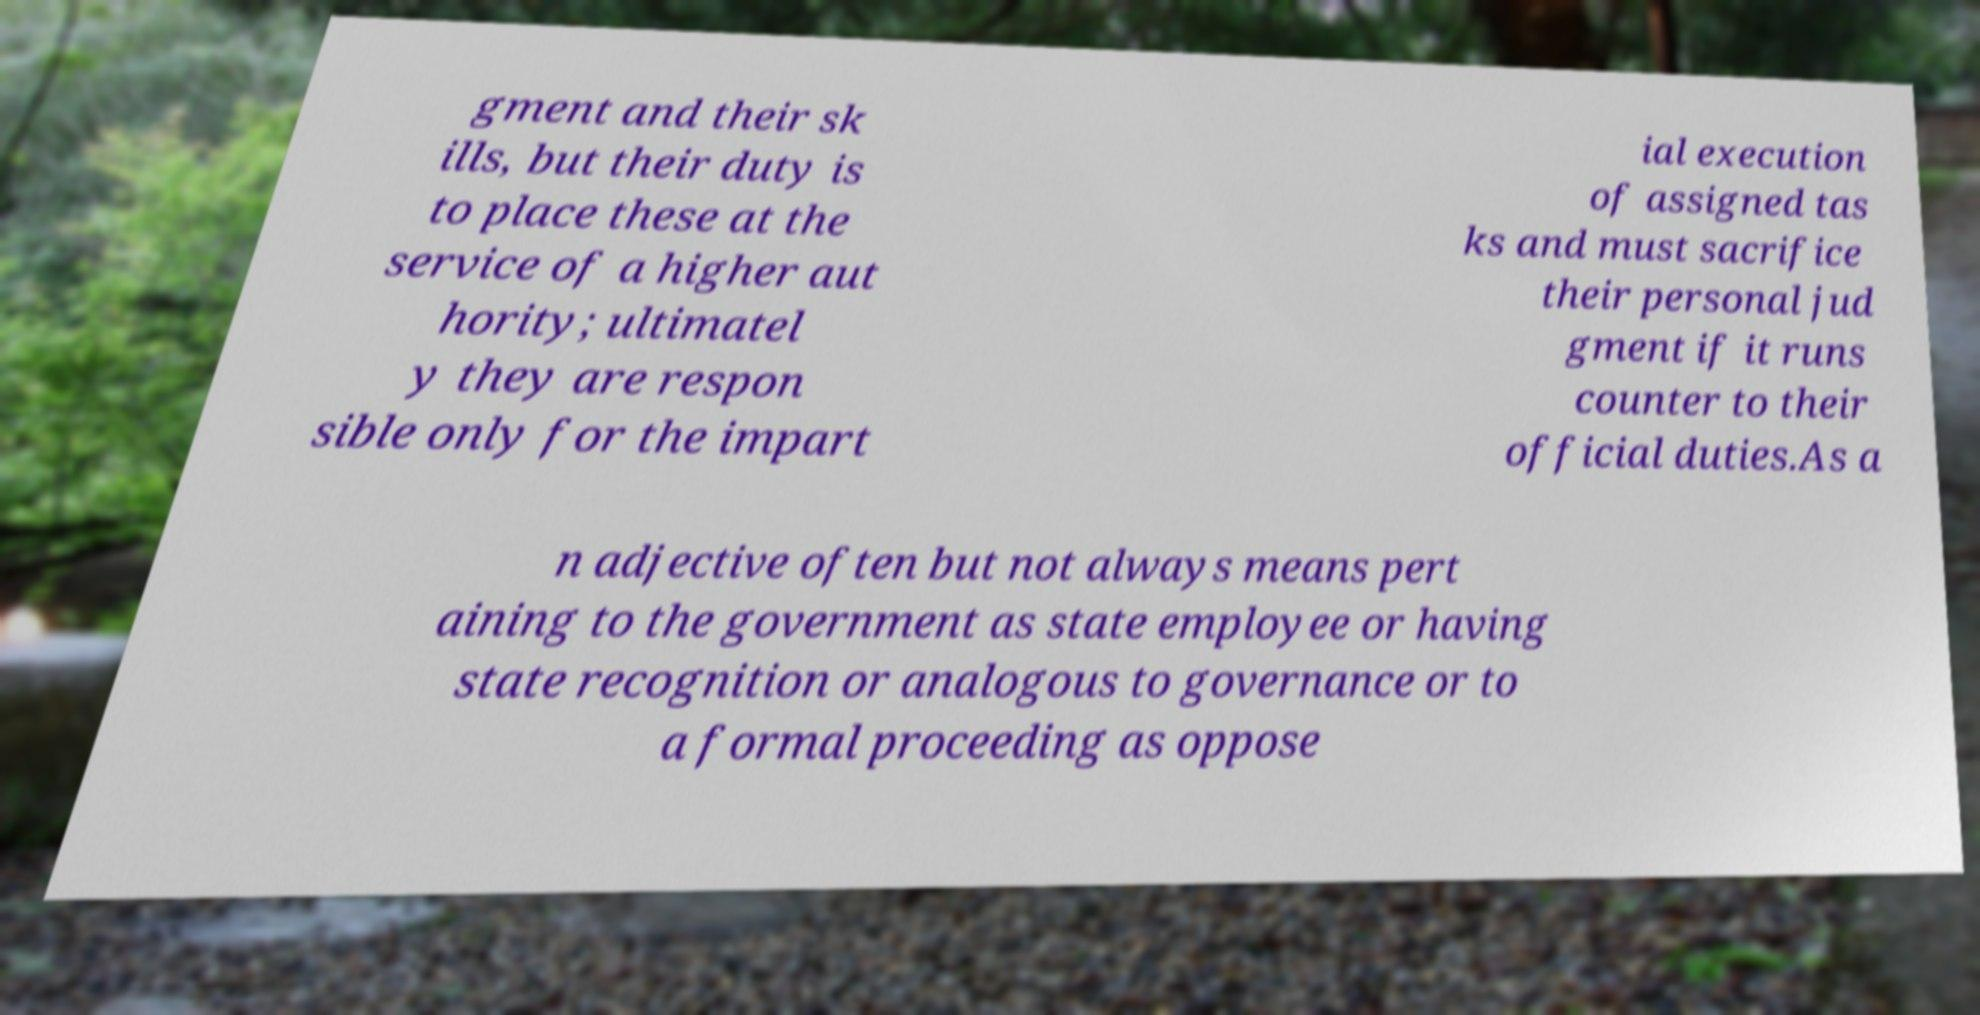Could you extract and type out the text from this image? gment and their sk ills, but their duty is to place these at the service of a higher aut hority; ultimatel y they are respon sible only for the impart ial execution of assigned tas ks and must sacrifice their personal jud gment if it runs counter to their official duties.As a n adjective often but not always means pert aining to the government as state employee or having state recognition or analogous to governance or to a formal proceeding as oppose 